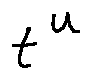<formula> <loc_0><loc_0><loc_500><loc_500>t ^ { u }</formula> 